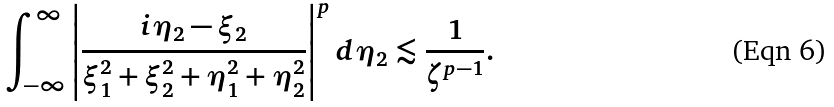Convert formula to latex. <formula><loc_0><loc_0><loc_500><loc_500>\int _ { - \infty } ^ { \infty } \left | \frac { i \eta _ { 2 } - \xi _ { 2 } } { \xi _ { 1 } ^ { 2 } + \xi _ { 2 } ^ { 2 } + \eta _ { 1 } ^ { 2 } + \eta _ { 2 } ^ { 2 } } \right | ^ { p } d \eta _ { 2 } \lesssim \frac { 1 } { \zeta ^ { p - 1 } } .</formula> 